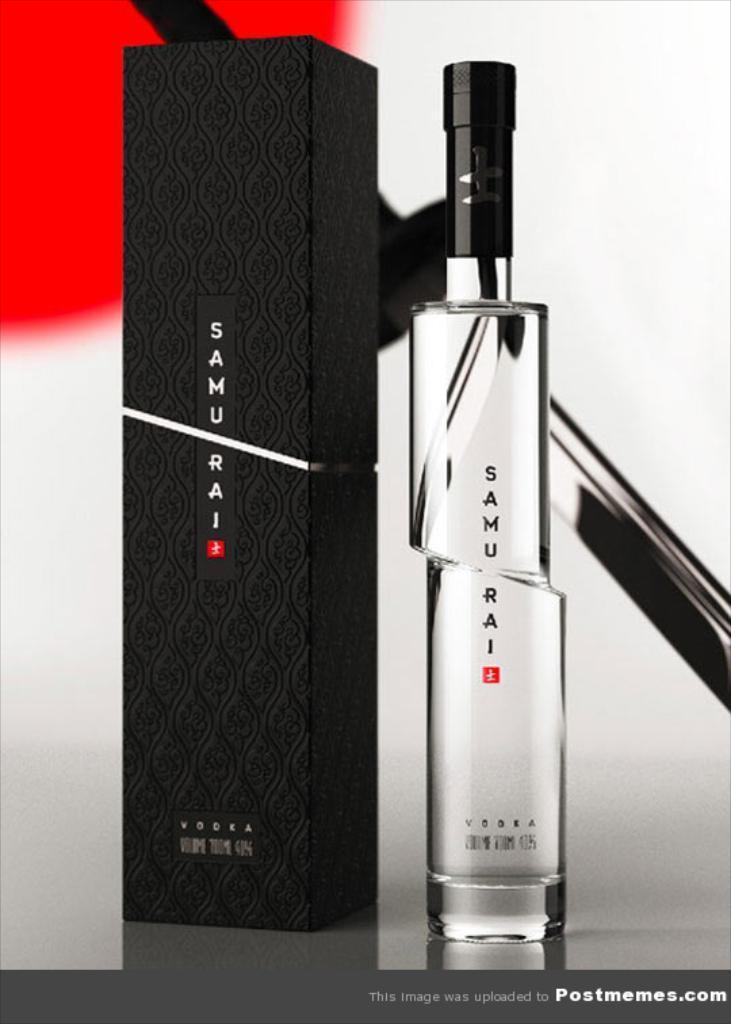Can you describe this image briefly? In this image we can see there is a bottle and box. And at the back there is a wall with a design. And there is a text written on the poster. 